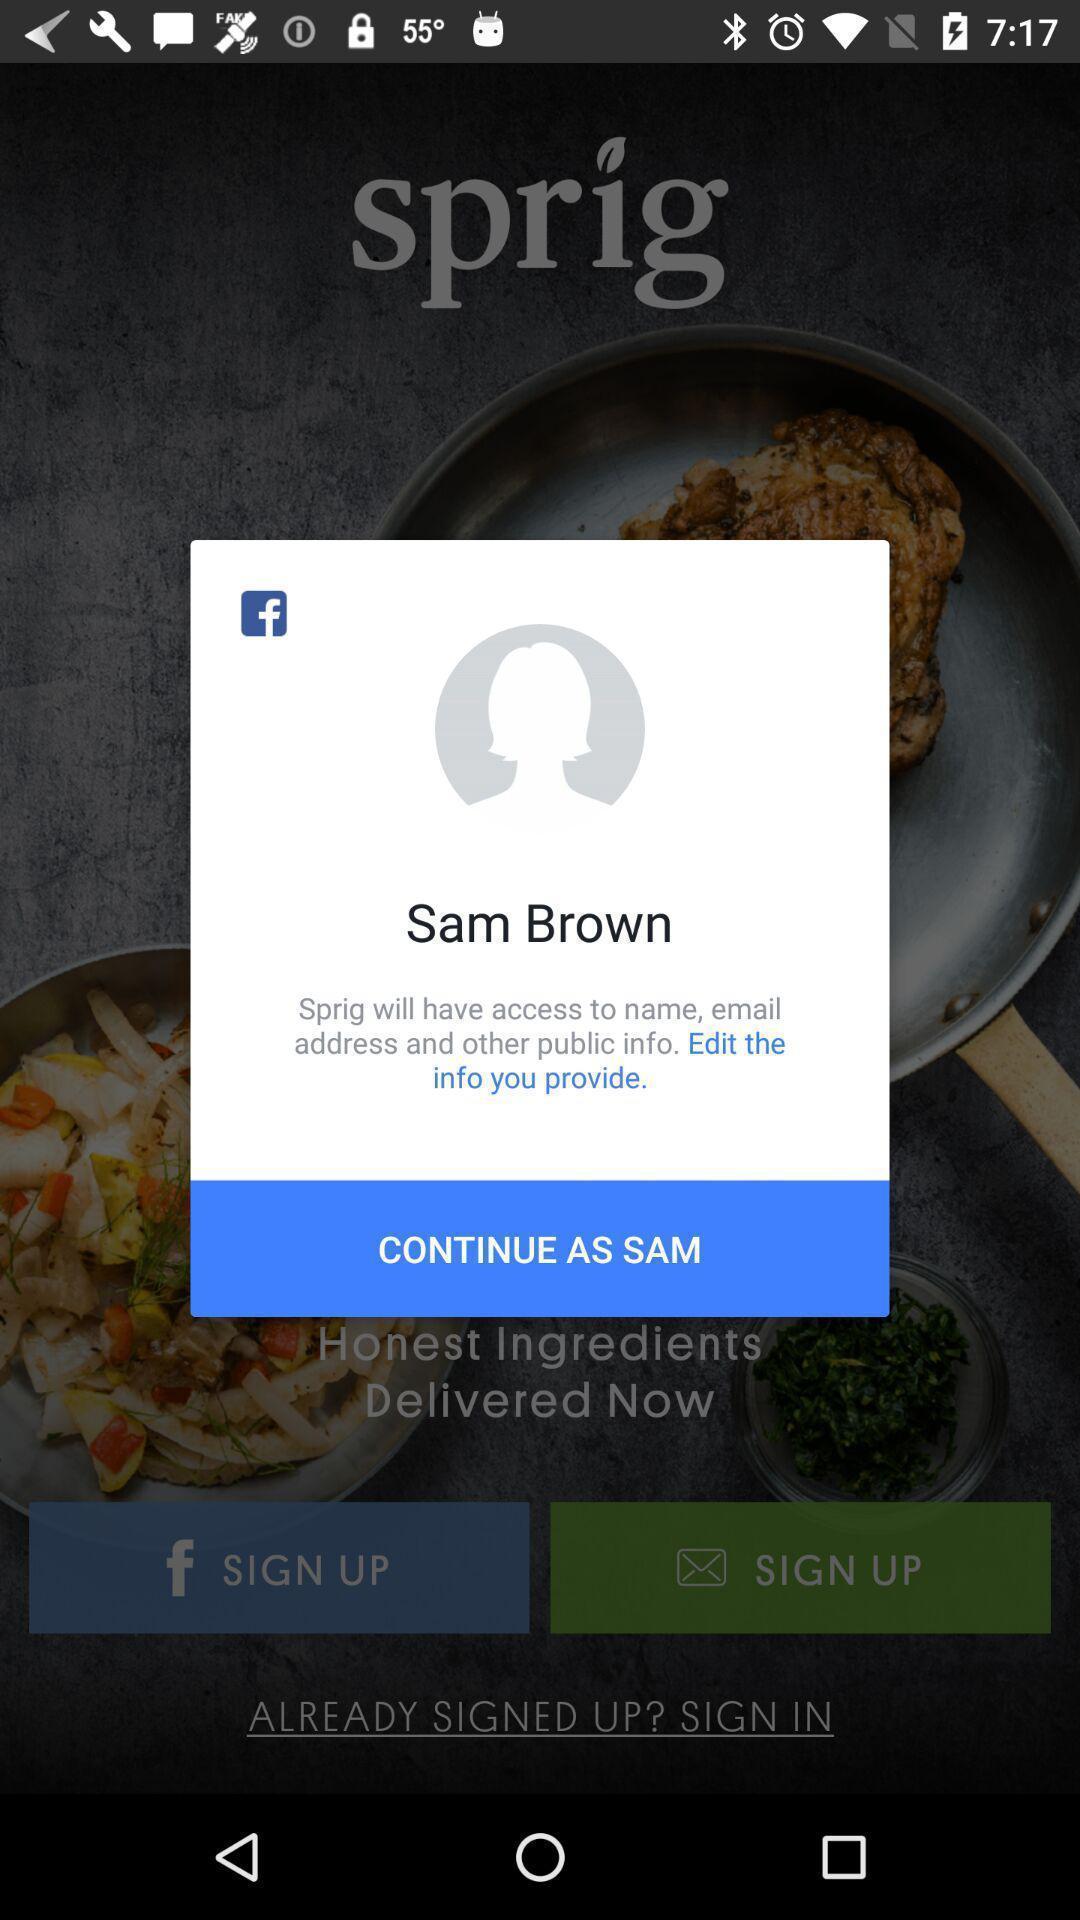Summarize the main components in this picture. Pop-up showing information about social networking profile. 